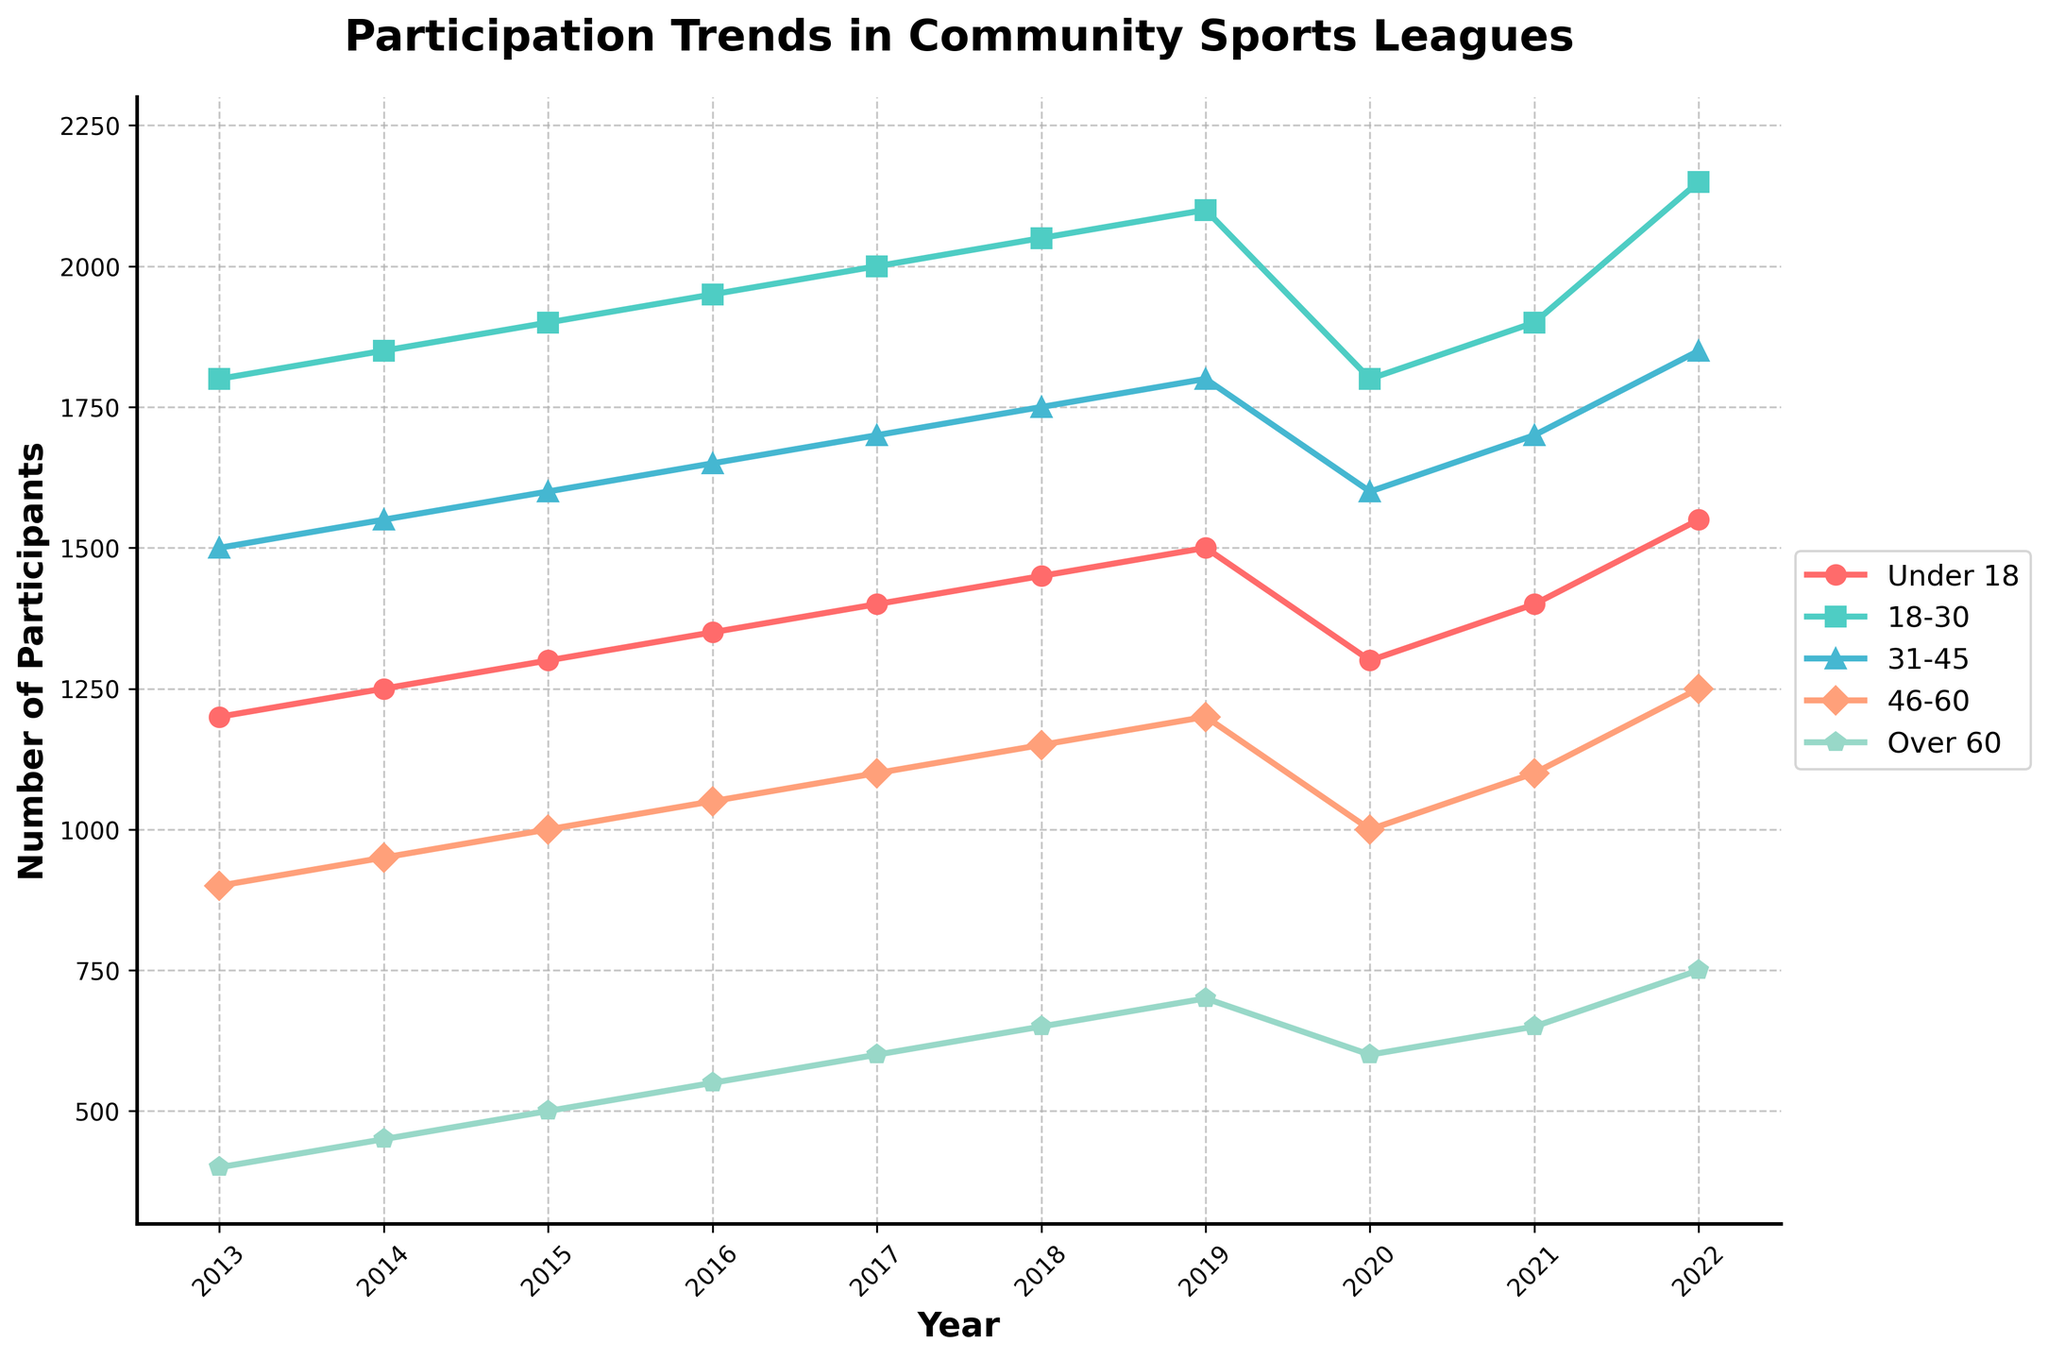What year had the lowest participation for the "Under 18" age group? Look for the lowest point in the "Under 18" line on the chart. The "Under 18" line is red, and the lowest point is at 2013.
Answer: 2013 Which age group had the highest participation in 2022? Look at the heights of the lines at the 2022 label on the x-axis. The highest line here is the green line representing the "18-30" age group.
Answer: 18-30 What is the difference in participation between the "31-45" and "46-60" age groups in 2020? Locate the data points for the "31-45" (blue) and "46-60" (orange) age groups for the year 2020. Subtract the participation of "46-60" (1000) from "31-45" (1600). 1600 - 1000 = 600.
Answer: 600 In which year did the "Over 60" age group first reach 600 participants? Examine the orange line along the y-axis values to find when it first meets or exceeds 600 participants. This occurs in 2017.
Answer: 2017 Which age group shows the most consistent increase in participation from 2013 to 2022? Compare the trajectories of the lines for each age group from 2013 to 2022. The "18-30" (green) age group shows a steady, consistent increase.
Answer: 18-30 How does the participation of the "Under 18" age group compare between 2019 and 2020? Locate the "Under 18" (red) data points for the years 2019 and 2020. Participation in 2019 is at 1500, and it decreases to 1300 in 2020.
Answer: Decreased What is the average participation of the "46-60" age group across all years? Add the participation values for the "46-60" age group from 2013 to 2022 and then divide by the number of years (10). (900+950+1000+1050+1100+1150+1200+1000+1100+1250) / 10 = 1070.
Answer: 1070 Which age group had the smallest drop in participation between 2019 and 2020? Calculate the difference in participation for each age group between 2019 and 2020 and compare. "Under 18": 1500-1300 = 200, "18-30": 2100-1800 = 300, "31-45": 1800-1600 = 200, "46-60": 1200-1000 = 200, "Over 60": 700-600 = 100. The "Over 60" group has the smallest drop.
Answer: Over 60 What is the total number of participants across all age groups in 2018? Sum the participation values for all age groups in 2018: 1450 + 2050 + 1750 + 1150 + 650 = 7050.
Answer: 7050 